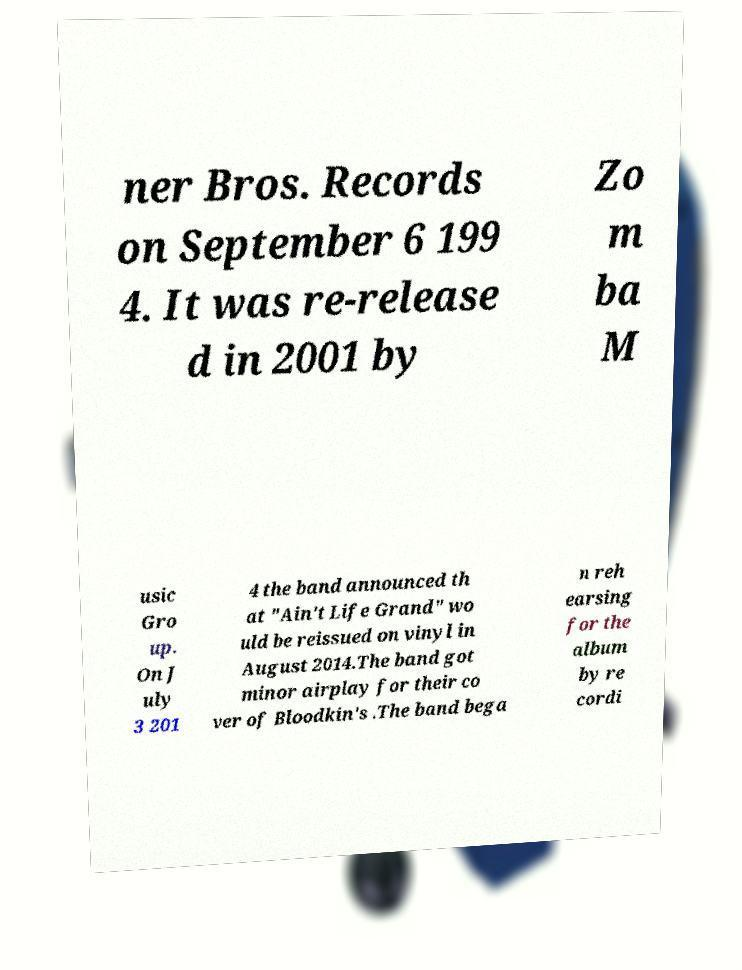For documentation purposes, I need the text within this image transcribed. Could you provide that? ner Bros. Records on September 6 199 4. It was re-release d in 2001 by Zo m ba M usic Gro up. On J uly 3 201 4 the band announced th at "Ain't Life Grand" wo uld be reissued on vinyl in August 2014.The band got minor airplay for their co ver of Bloodkin's .The band bega n reh earsing for the album by re cordi 